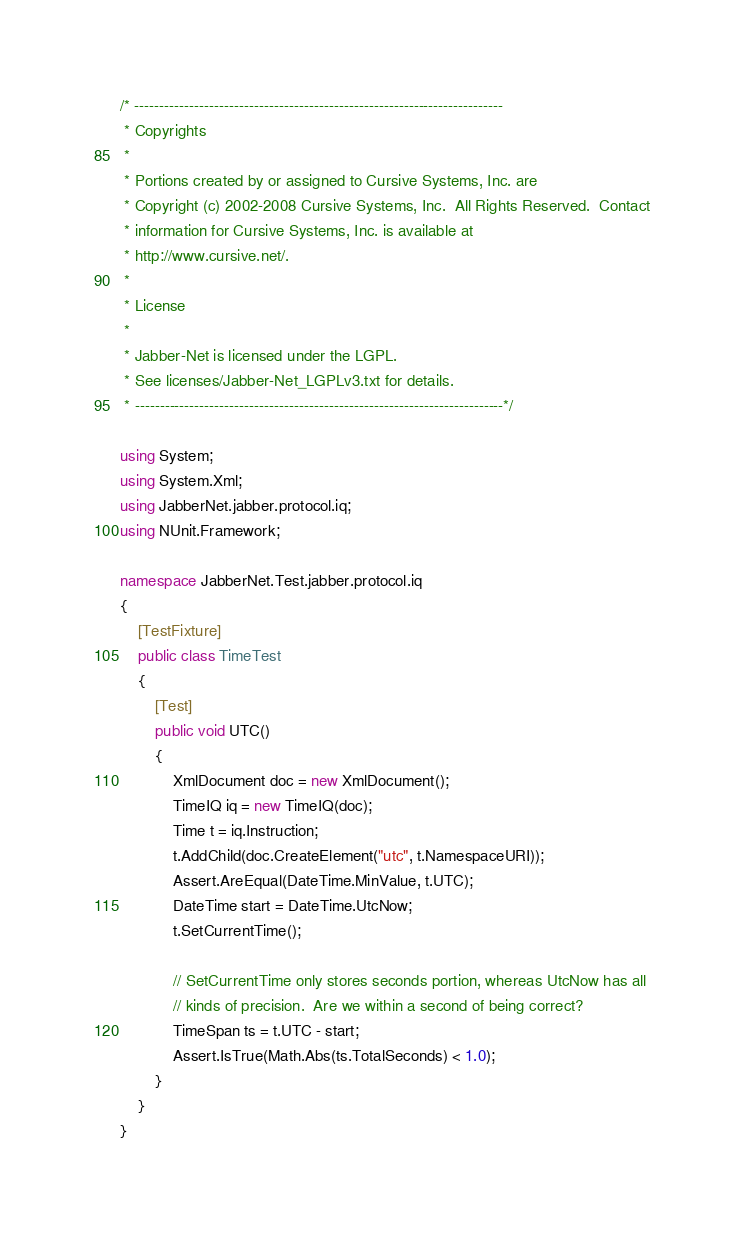Convert code to text. <code><loc_0><loc_0><loc_500><loc_500><_C#_>/* --------------------------------------------------------------------------
 * Copyrights
 *
 * Portions created by or assigned to Cursive Systems, Inc. are
 * Copyright (c) 2002-2008 Cursive Systems, Inc.  All Rights Reserved.  Contact
 * information for Cursive Systems, Inc. is available at
 * http://www.cursive.net/.
 *
 * License
 *
 * Jabber-Net is licensed under the LGPL.
 * See licenses/Jabber-Net_LGPLv3.txt for details.
 * --------------------------------------------------------------------------*/

using System;
using System.Xml;
using JabberNet.jabber.protocol.iq;
using NUnit.Framework;

namespace JabberNet.Test.jabber.protocol.iq
{
    [TestFixture]
    public class TimeTest
    {
        [Test]
        public void UTC()
        {
            XmlDocument doc = new XmlDocument();
            TimeIQ iq = new TimeIQ(doc);
            Time t = iq.Instruction;
            t.AddChild(doc.CreateElement("utc", t.NamespaceURI));
            Assert.AreEqual(DateTime.MinValue, t.UTC);
            DateTime start = DateTime.UtcNow;
            t.SetCurrentTime();

            // SetCurrentTime only stores seconds portion, whereas UtcNow has all
            // kinds of precision.  Are we within a second of being correct?
            TimeSpan ts = t.UTC - start;
            Assert.IsTrue(Math.Abs(ts.TotalSeconds) < 1.0);
        }
    }
}
</code> 